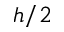Convert formula to latex. <formula><loc_0><loc_0><loc_500><loc_500>h / 2</formula> 